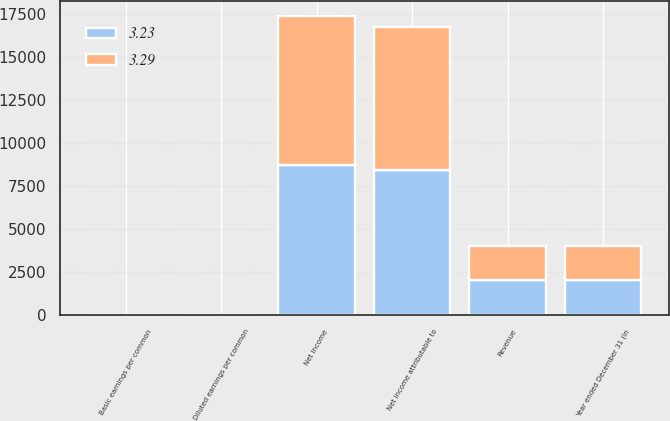Convert chart to OTSL. <chart><loc_0><loc_0><loc_500><loc_500><stacked_bar_chart><ecel><fcel>Year ended December 31 (in<fcel>Revenue<fcel>Net income<fcel>Net income attributable to<fcel>Basic earnings per common<fcel>Diluted earnings per common<nl><fcel>3.29<fcel>2015<fcel>2014.5<fcel>8640<fcel>8278<fcel>3.33<fcel>3.29<nl><fcel>3.23<fcel>2014<fcel>2014.5<fcel>8758<fcel>8463<fcel>3.28<fcel>3.23<nl></chart> 